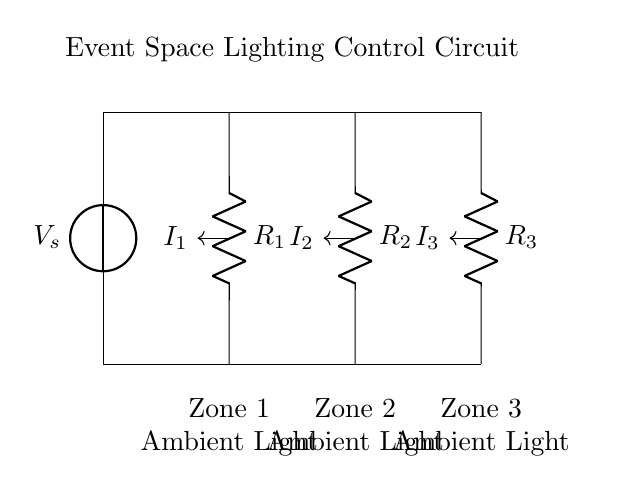What is the voltage source in this circuit? The voltage source is labeled Va and is located at the top left of the circuit. It provides the electrical potential needed for the rest of the circuit to function.
Answer: Va How many resistors are present in the circuit? There are three resistors present in the circuit, labeled R1, R2, and R3, each connected to different zones of the event space.
Answer: Three What is the total current flowing into the circuit? The total current is the sum of the currents I1, I2, and I3 coming from the voltage source towards each resistor. Although not directly specified, it is implied to be split among the three branches.
Answer: I_total Which resistor is associated with Zone 2? Zone 2 is connected to R2, which is the resistor in the middle of the circuit design and provides ambient light for that specific zone.
Answer: R2 How does the current divide among the zones? The current divides in a manner that's inversely proportional to the resistance values of each resistor, meaning lower resistance will receive a larger share of the current, a key characteristic of current divider circuits.
Answer: Inversely proportional What is the purpose of this circuit? The purpose of this circuit is to control ambient lighting for different zones in a large event space, allowing for tailored lighting solutions depending on the needs of each area.
Answer: Control ambient lighting What type of circuit is this? This is a current divider circuit, as it splits the input current into different paths corresponding to different resistors, each controlling the lighting for specific zones.
Answer: Current divider 